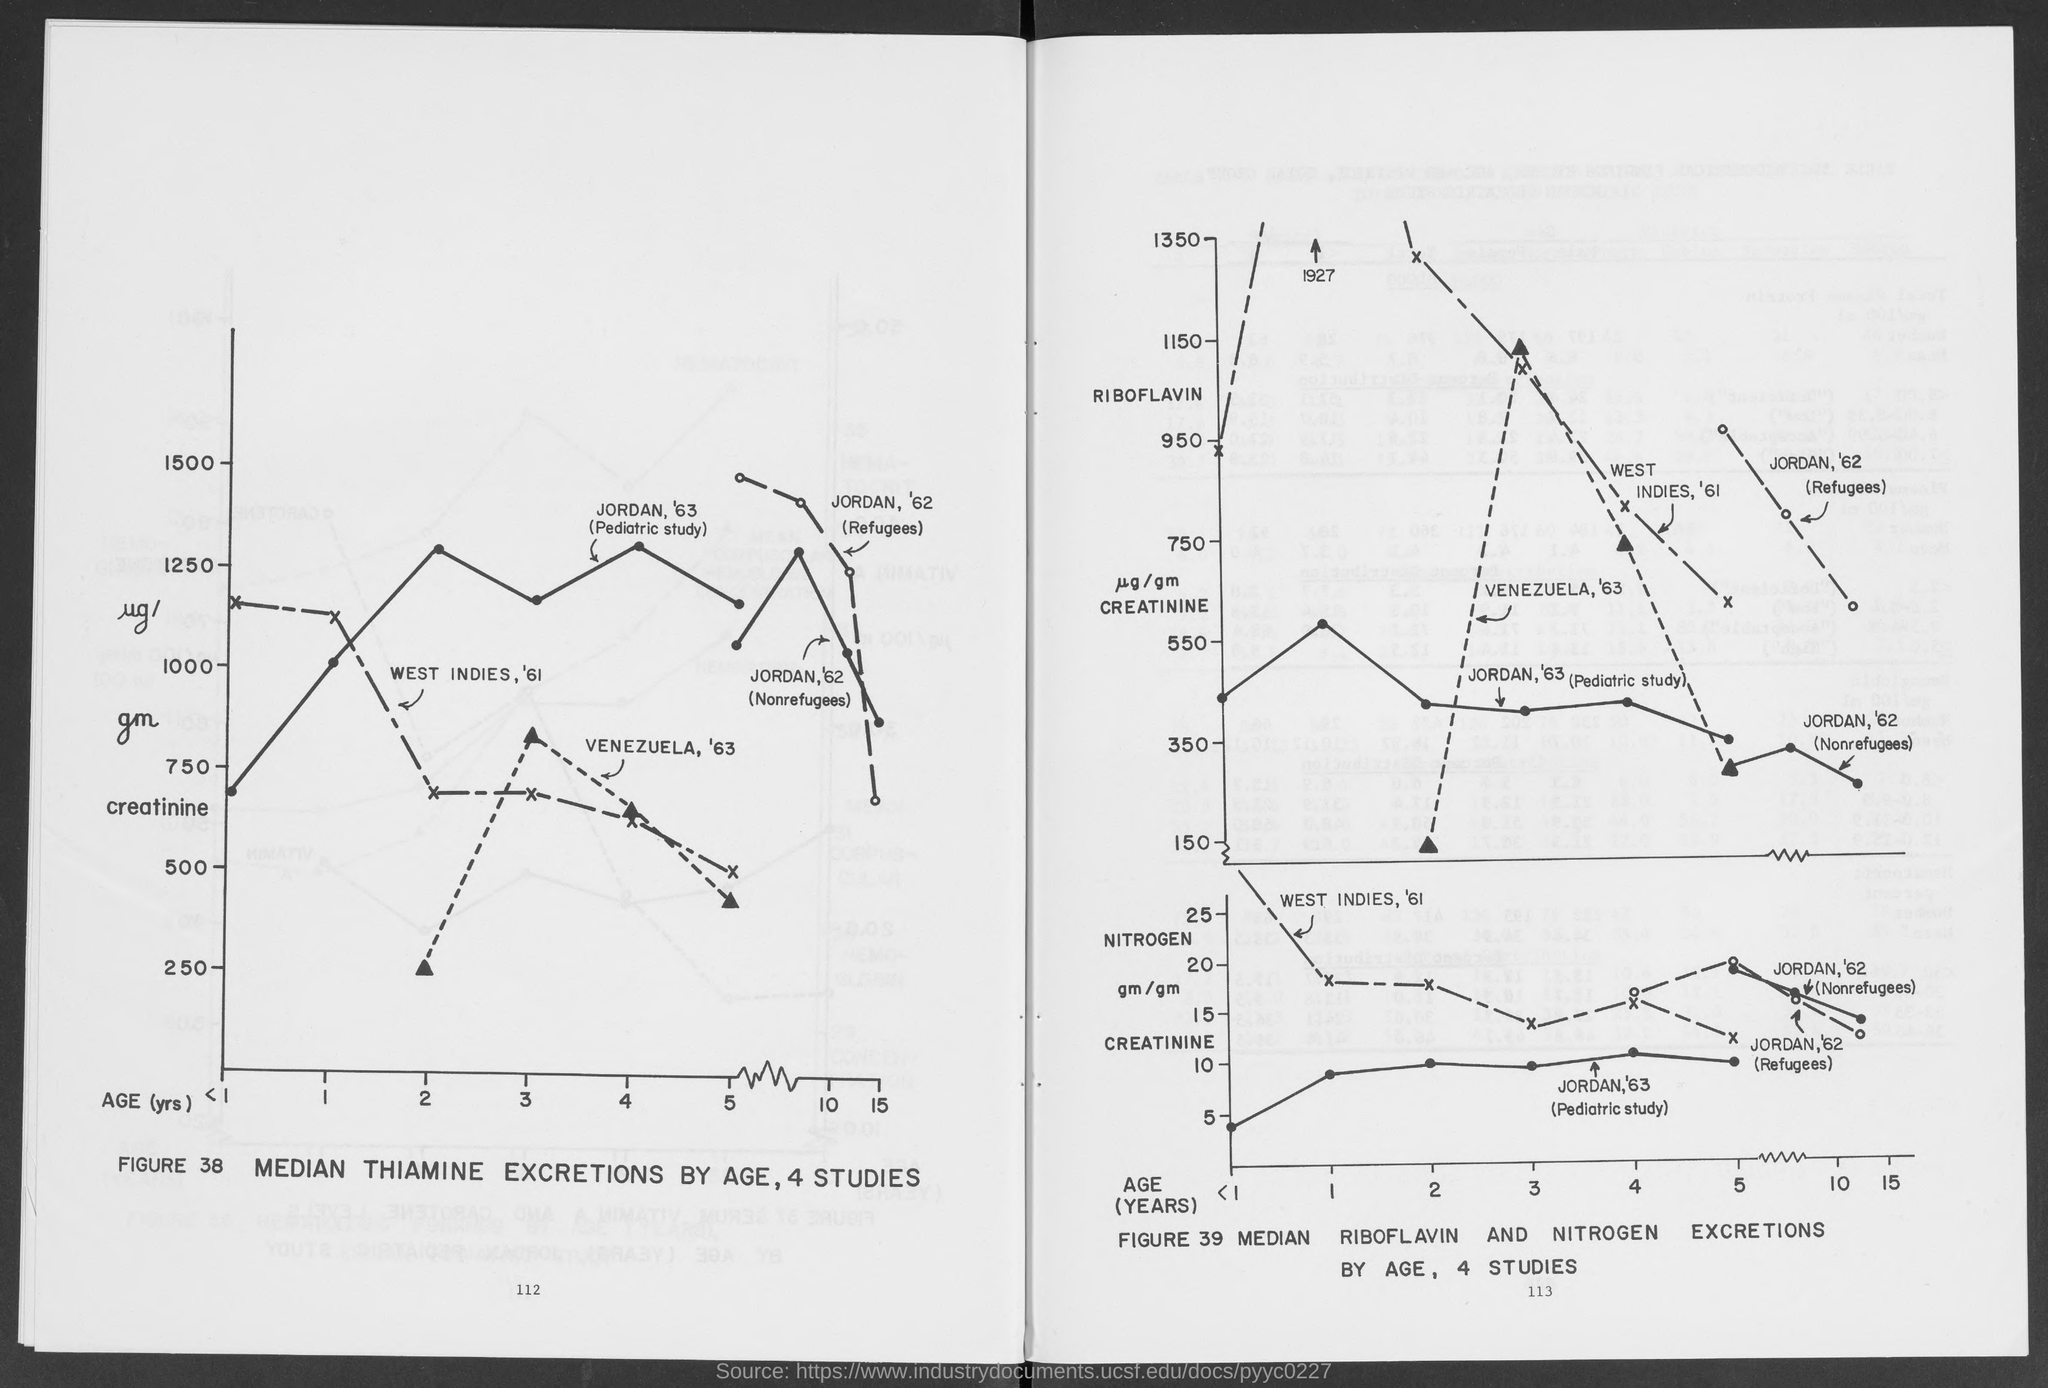What is the Creatinine for median thiamine excretions for Age 2 years for Venezuela, '63?
Offer a terse response. 250. 